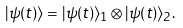<formula> <loc_0><loc_0><loc_500><loc_500>| \psi ( t ) \rangle = | \psi ( t ) \rangle _ { 1 } \otimes | \psi ( t ) \rangle _ { 2 } .</formula> 